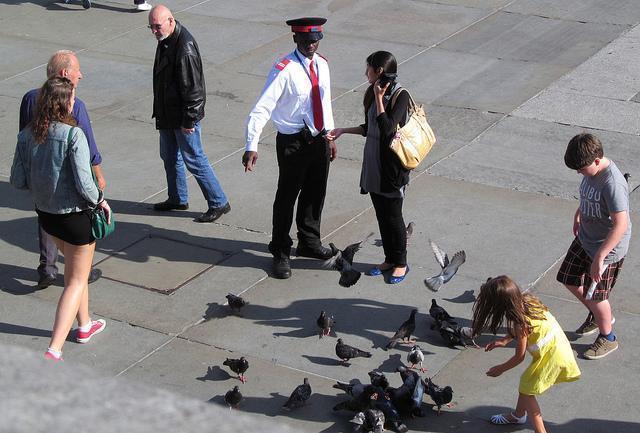What does the girl in yellow do to the birds?
Select the accurate answer and provide justification: `Answer: choice
Rationale: srationale.`
Options: Hide, grab them, hit them, feed them. Answer: feed them.
Rationale: The girl has some food on her hand. 